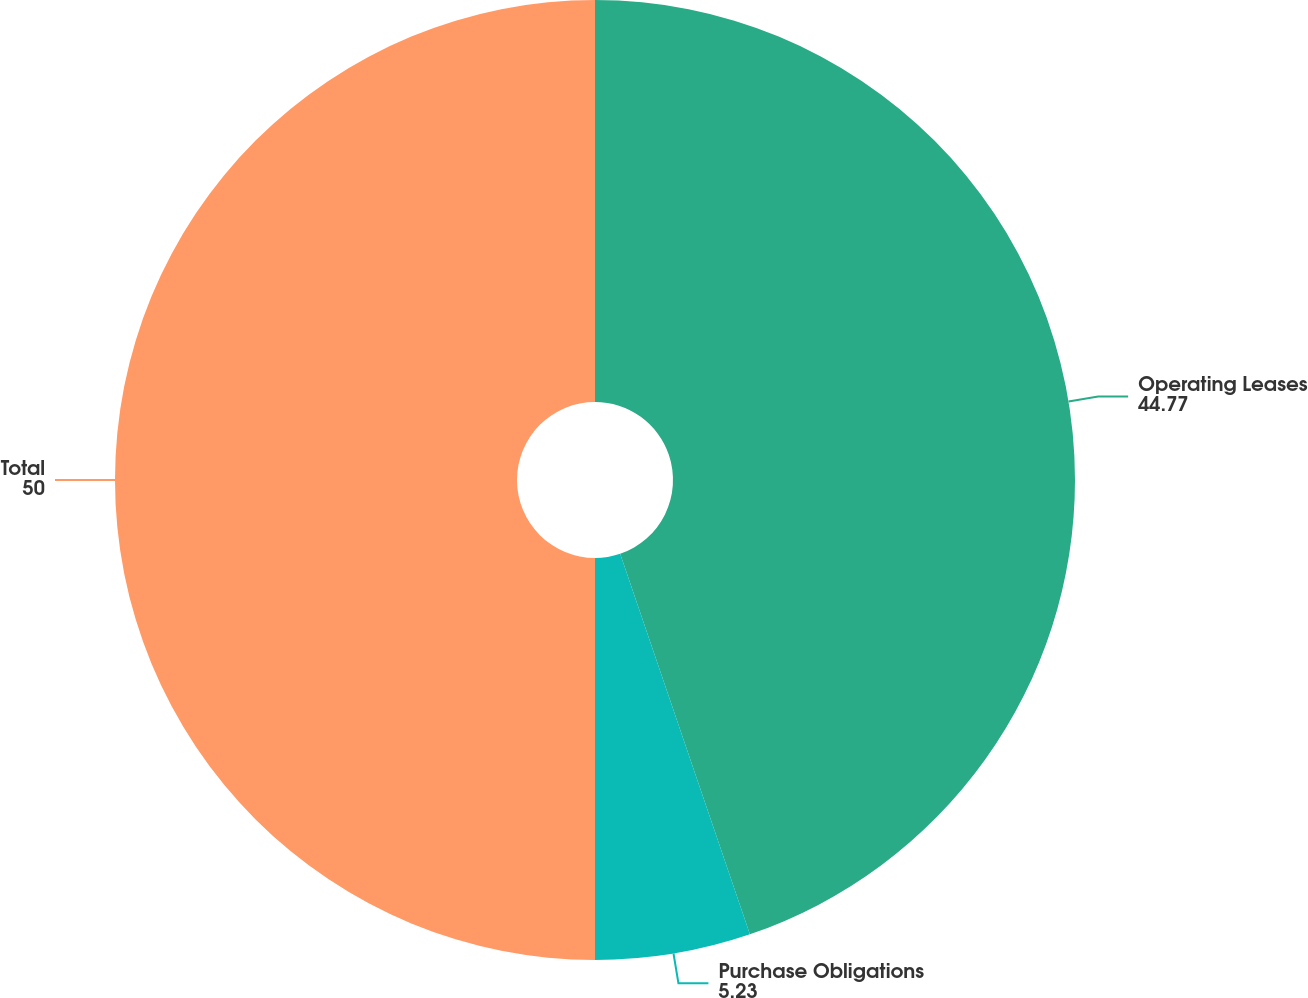Convert chart. <chart><loc_0><loc_0><loc_500><loc_500><pie_chart><fcel>Operating Leases<fcel>Purchase Obligations<fcel>Total<nl><fcel>44.77%<fcel>5.23%<fcel>50.0%<nl></chart> 